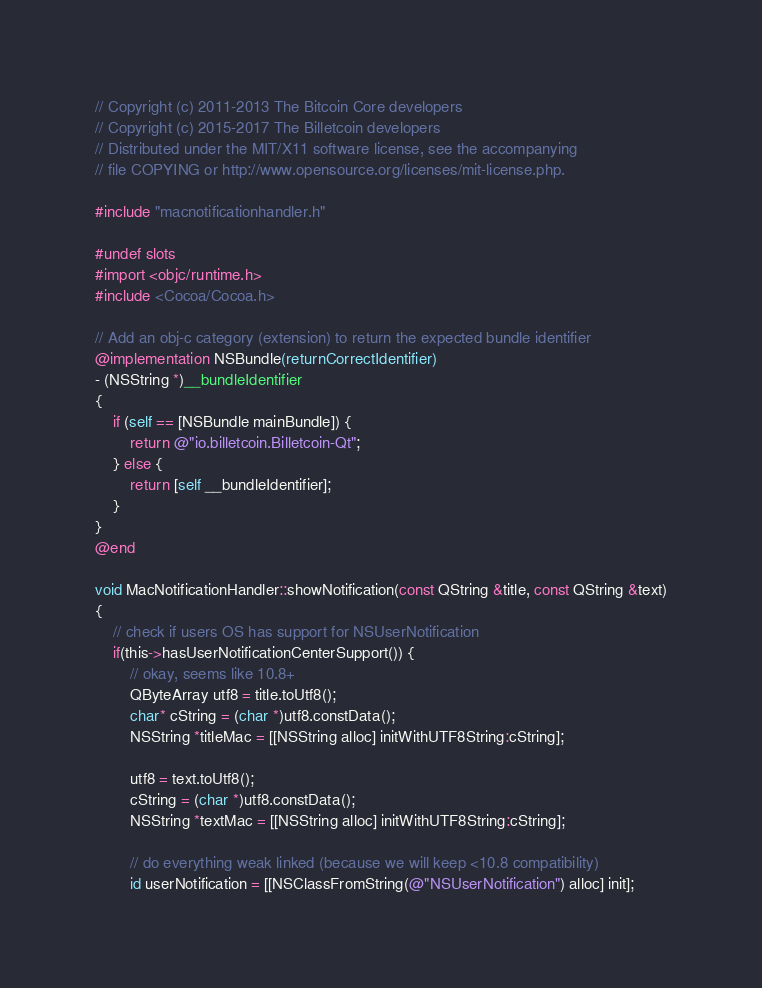Convert code to text. <code><loc_0><loc_0><loc_500><loc_500><_ObjectiveC_>// Copyright (c) 2011-2013 The Bitcoin Core developers
// Copyright (c) 2015-2017 The Billetcoin developers
// Distributed under the MIT/X11 software license, see the accompanying
// file COPYING or http://www.opensource.org/licenses/mit-license.php.

#include "macnotificationhandler.h"

#undef slots
#import <objc/runtime.h>
#include <Cocoa/Cocoa.h>

// Add an obj-c category (extension) to return the expected bundle identifier
@implementation NSBundle(returnCorrectIdentifier)
- (NSString *)__bundleIdentifier
{
    if (self == [NSBundle mainBundle]) {
        return @"io.billetcoin.Billetcoin-Qt";
    } else {
        return [self __bundleIdentifier];
    }
}
@end

void MacNotificationHandler::showNotification(const QString &title, const QString &text)
{
    // check if users OS has support for NSUserNotification
    if(this->hasUserNotificationCenterSupport()) {
        // okay, seems like 10.8+
        QByteArray utf8 = title.toUtf8();
        char* cString = (char *)utf8.constData();
        NSString *titleMac = [[NSString alloc] initWithUTF8String:cString];

        utf8 = text.toUtf8();
        cString = (char *)utf8.constData();
        NSString *textMac = [[NSString alloc] initWithUTF8String:cString];

        // do everything weak linked (because we will keep <10.8 compatibility)
        id userNotification = [[NSClassFromString(@"NSUserNotification") alloc] init];</code> 